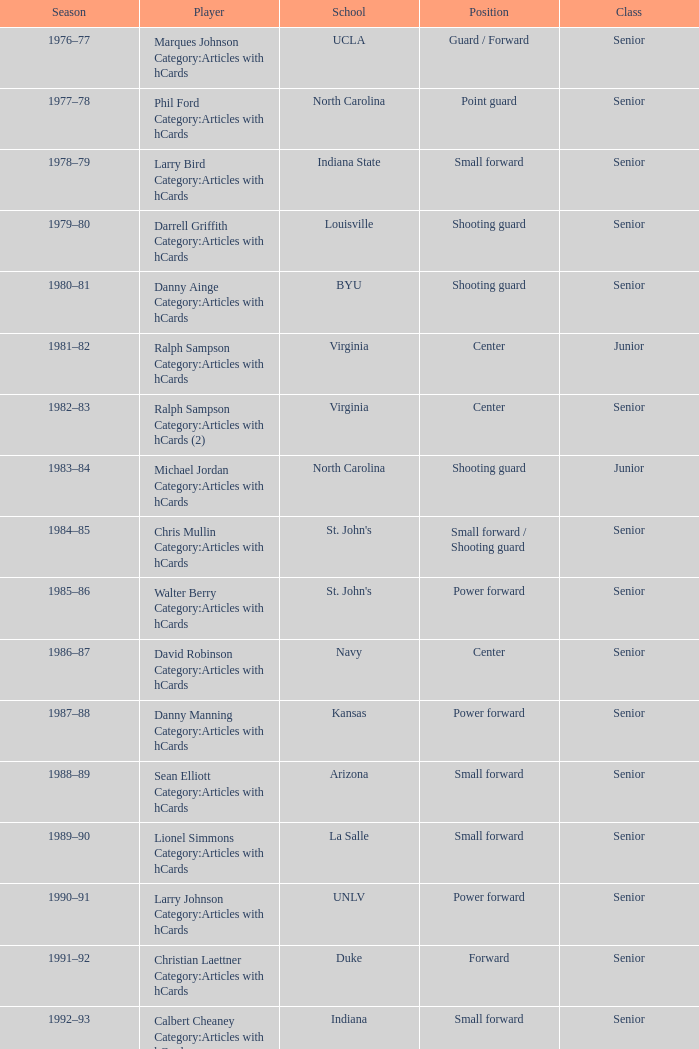Name the position for indiana state Small forward. 